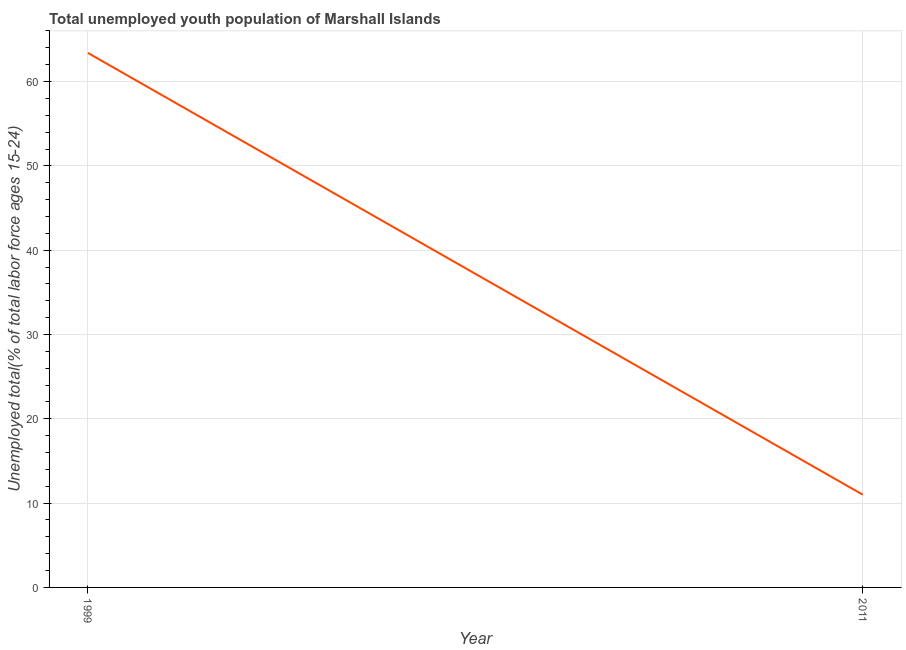What is the unemployed youth in 1999?
Keep it short and to the point. 63.4. Across all years, what is the maximum unemployed youth?
Keep it short and to the point. 63.4. In which year was the unemployed youth maximum?
Ensure brevity in your answer.  1999. In which year was the unemployed youth minimum?
Your answer should be very brief. 2011. What is the sum of the unemployed youth?
Give a very brief answer. 74.4. What is the difference between the unemployed youth in 1999 and 2011?
Offer a terse response. 52.4. What is the average unemployed youth per year?
Keep it short and to the point. 37.2. What is the median unemployed youth?
Make the answer very short. 37.2. What is the ratio of the unemployed youth in 1999 to that in 2011?
Provide a succinct answer. 5.76. Is the unemployed youth in 1999 less than that in 2011?
Offer a terse response. No. Does the unemployed youth monotonically increase over the years?
Provide a succinct answer. No. How many years are there in the graph?
Your answer should be very brief. 2. Are the values on the major ticks of Y-axis written in scientific E-notation?
Keep it short and to the point. No. Does the graph contain any zero values?
Offer a very short reply. No. Does the graph contain grids?
Your response must be concise. Yes. What is the title of the graph?
Make the answer very short. Total unemployed youth population of Marshall Islands. What is the label or title of the Y-axis?
Your response must be concise. Unemployed total(% of total labor force ages 15-24). What is the Unemployed total(% of total labor force ages 15-24) in 1999?
Provide a succinct answer. 63.4. What is the Unemployed total(% of total labor force ages 15-24) of 2011?
Provide a succinct answer. 11. What is the difference between the Unemployed total(% of total labor force ages 15-24) in 1999 and 2011?
Offer a terse response. 52.4. What is the ratio of the Unemployed total(% of total labor force ages 15-24) in 1999 to that in 2011?
Provide a short and direct response. 5.76. 